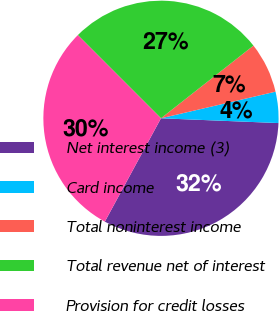Convert chart. <chart><loc_0><loc_0><loc_500><loc_500><pie_chart><fcel>Net interest income (3)<fcel>Card income<fcel>Total noninterest income<fcel>Total revenue net of interest<fcel>Provision for credit losses<nl><fcel>32.28%<fcel>4.28%<fcel>6.97%<fcel>26.9%<fcel>29.59%<nl></chart> 